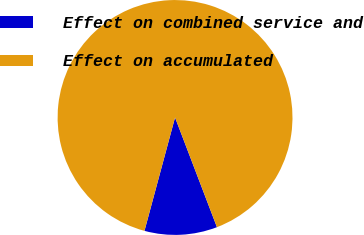Convert chart to OTSL. <chart><loc_0><loc_0><loc_500><loc_500><pie_chart><fcel>Effect on combined service and<fcel>Effect on accumulated<nl><fcel>10.0%<fcel>90.0%<nl></chart> 